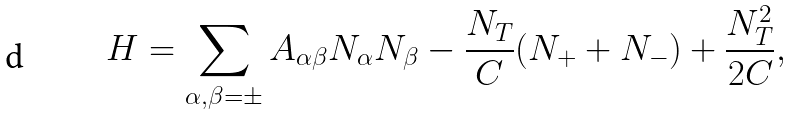Convert formula to latex. <formula><loc_0><loc_0><loc_500><loc_500>H = \sum _ { \alpha , \beta = \pm } A _ { \alpha \beta } N _ { \alpha } N _ { \beta } - \frac { N _ { T } } { C } ( N _ { + } + N _ { - } ) + \frac { N _ { T } ^ { 2 } } { 2 C } ,</formula> 